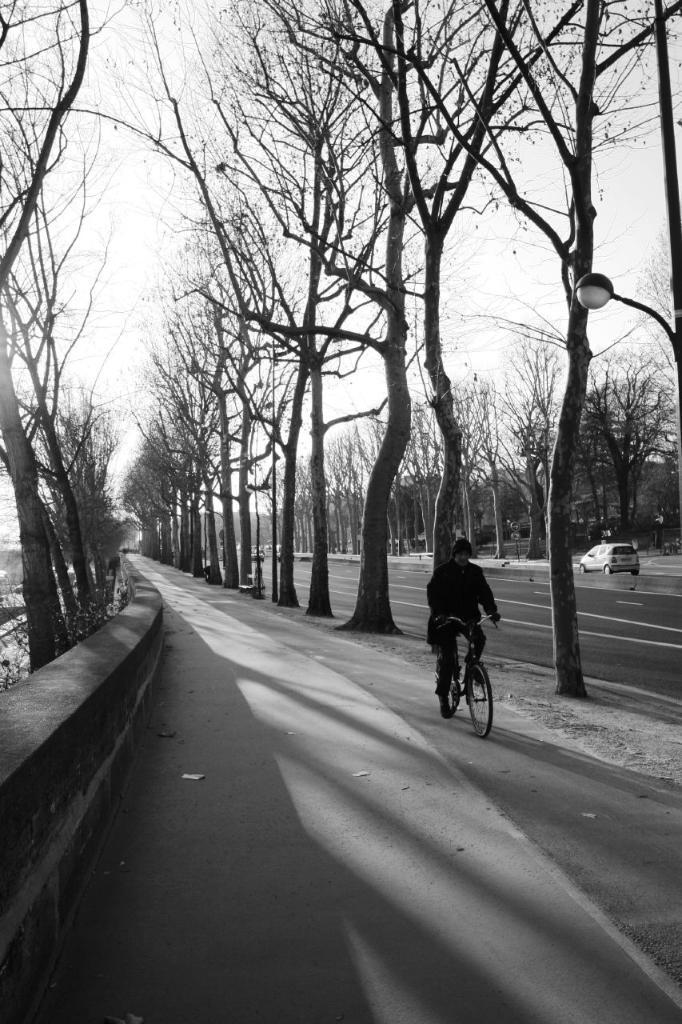What is the main subject of the image? There is a person riding a bicycle in the image. What can be seen in the background of the image? There are trees and a road visible in the background of the image. Are there any other vehicles or objects in the background? Yes, there is a vehicle in the background of the image. What type of nut is being used to fix the bicycle in the image? There is no nut or any indication of a bicycle repair in the image; it simply shows a person riding a bicycle. 